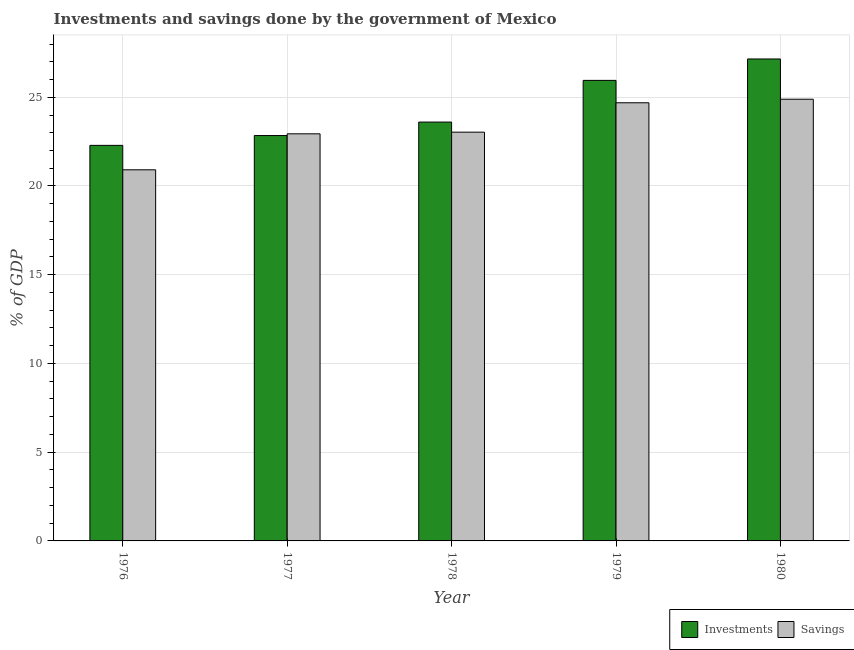How many groups of bars are there?
Provide a succinct answer. 5. Are the number of bars per tick equal to the number of legend labels?
Your response must be concise. Yes. Are the number of bars on each tick of the X-axis equal?
Give a very brief answer. Yes. How many bars are there on the 1st tick from the left?
Ensure brevity in your answer.  2. How many bars are there on the 3rd tick from the right?
Make the answer very short. 2. What is the label of the 4th group of bars from the left?
Give a very brief answer. 1979. In how many cases, is the number of bars for a given year not equal to the number of legend labels?
Your answer should be compact. 0. What is the savings of government in 1977?
Ensure brevity in your answer.  22.94. Across all years, what is the maximum savings of government?
Ensure brevity in your answer.  24.89. Across all years, what is the minimum savings of government?
Keep it short and to the point. 20.91. In which year was the savings of government minimum?
Ensure brevity in your answer.  1976. What is the total investments of government in the graph?
Provide a succinct answer. 121.84. What is the difference between the investments of government in 1976 and that in 1978?
Ensure brevity in your answer.  -1.31. What is the difference between the savings of government in 1978 and the investments of government in 1977?
Offer a terse response. 0.09. What is the average investments of government per year?
Offer a terse response. 24.37. In how many years, is the investments of government greater than 10 %?
Ensure brevity in your answer.  5. What is the ratio of the savings of government in 1976 to that in 1980?
Offer a very short reply. 0.84. Is the savings of government in 1976 less than that in 1978?
Provide a succinct answer. Yes. Is the difference between the investments of government in 1976 and 1980 greater than the difference between the savings of government in 1976 and 1980?
Provide a short and direct response. No. What is the difference between the highest and the second highest savings of government?
Keep it short and to the point. 0.2. What is the difference between the highest and the lowest savings of government?
Give a very brief answer. 3.98. In how many years, is the investments of government greater than the average investments of government taken over all years?
Make the answer very short. 2. Is the sum of the investments of government in 1976 and 1977 greater than the maximum savings of government across all years?
Your answer should be very brief. Yes. What does the 1st bar from the left in 1980 represents?
Ensure brevity in your answer.  Investments. What does the 2nd bar from the right in 1978 represents?
Your answer should be compact. Investments. How many years are there in the graph?
Provide a short and direct response. 5. What is the difference between two consecutive major ticks on the Y-axis?
Offer a very short reply. 5. Are the values on the major ticks of Y-axis written in scientific E-notation?
Your answer should be very brief. No. Does the graph contain any zero values?
Ensure brevity in your answer.  No. Does the graph contain grids?
Your response must be concise. Yes. How are the legend labels stacked?
Ensure brevity in your answer.  Horizontal. What is the title of the graph?
Your answer should be compact. Investments and savings done by the government of Mexico. Does "Public funds" appear as one of the legend labels in the graph?
Provide a short and direct response. No. What is the label or title of the X-axis?
Offer a terse response. Year. What is the label or title of the Y-axis?
Ensure brevity in your answer.  % of GDP. What is the % of GDP of Investments in 1976?
Provide a short and direct response. 22.29. What is the % of GDP in Savings in 1976?
Offer a very short reply. 20.91. What is the % of GDP of Investments in 1977?
Your response must be concise. 22.84. What is the % of GDP of Savings in 1977?
Keep it short and to the point. 22.94. What is the % of GDP in Investments in 1978?
Ensure brevity in your answer.  23.6. What is the % of GDP in Savings in 1978?
Offer a very short reply. 23.03. What is the % of GDP of Investments in 1979?
Offer a terse response. 25.95. What is the % of GDP of Savings in 1979?
Keep it short and to the point. 24.69. What is the % of GDP of Investments in 1980?
Provide a short and direct response. 27.16. What is the % of GDP of Savings in 1980?
Give a very brief answer. 24.89. Across all years, what is the maximum % of GDP in Investments?
Give a very brief answer. 27.16. Across all years, what is the maximum % of GDP of Savings?
Your answer should be very brief. 24.89. Across all years, what is the minimum % of GDP of Investments?
Provide a succinct answer. 22.29. Across all years, what is the minimum % of GDP in Savings?
Make the answer very short. 20.91. What is the total % of GDP in Investments in the graph?
Your response must be concise. 121.84. What is the total % of GDP of Savings in the graph?
Offer a terse response. 116.46. What is the difference between the % of GDP of Investments in 1976 and that in 1977?
Ensure brevity in your answer.  -0.55. What is the difference between the % of GDP in Savings in 1976 and that in 1977?
Provide a short and direct response. -2.03. What is the difference between the % of GDP in Investments in 1976 and that in 1978?
Provide a succinct answer. -1.31. What is the difference between the % of GDP of Savings in 1976 and that in 1978?
Provide a succinct answer. -2.12. What is the difference between the % of GDP in Investments in 1976 and that in 1979?
Offer a very short reply. -3.66. What is the difference between the % of GDP in Savings in 1976 and that in 1979?
Offer a very short reply. -3.78. What is the difference between the % of GDP of Investments in 1976 and that in 1980?
Give a very brief answer. -4.87. What is the difference between the % of GDP of Savings in 1976 and that in 1980?
Provide a succinct answer. -3.98. What is the difference between the % of GDP of Investments in 1977 and that in 1978?
Give a very brief answer. -0.76. What is the difference between the % of GDP of Savings in 1977 and that in 1978?
Your response must be concise. -0.09. What is the difference between the % of GDP of Investments in 1977 and that in 1979?
Keep it short and to the point. -3.11. What is the difference between the % of GDP in Savings in 1977 and that in 1979?
Give a very brief answer. -1.75. What is the difference between the % of GDP of Investments in 1977 and that in 1980?
Give a very brief answer. -4.31. What is the difference between the % of GDP in Savings in 1977 and that in 1980?
Make the answer very short. -1.95. What is the difference between the % of GDP in Investments in 1978 and that in 1979?
Provide a short and direct response. -2.35. What is the difference between the % of GDP of Savings in 1978 and that in 1979?
Ensure brevity in your answer.  -1.66. What is the difference between the % of GDP of Investments in 1978 and that in 1980?
Provide a succinct answer. -3.56. What is the difference between the % of GDP of Savings in 1978 and that in 1980?
Provide a short and direct response. -1.86. What is the difference between the % of GDP in Investments in 1979 and that in 1980?
Ensure brevity in your answer.  -1.21. What is the difference between the % of GDP of Savings in 1979 and that in 1980?
Provide a succinct answer. -0.2. What is the difference between the % of GDP of Investments in 1976 and the % of GDP of Savings in 1977?
Your response must be concise. -0.65. What is the difference between the % of GDP of Investments in 1976 and the % of GDP of Savings in 1978?
Ensure brevity in your answer.  -0.74. What is the difference between the % of GDP in Investments in 1976 and the % of GDP in Savings in 1979?
Offer a very short reply. -2.4. What is the difference between the % of GDP in Investments in 1976 and the % of GDP in Savings in 1980?
Your answer should be very brief. -2.6. What is the difference between the % of GDP in Investments in 1977 and the % of GDP in Savings in 1978?
Give a very brief answer. -0.19. What is the difference between the % of GDP of Investments in 1977 and the % of GDP of Savings in 1979?
Offer a very short reply. -1.85. What is the difference between the % of GDP of Investments in 1977 and the % of GDP of Savings in 1980?
Make the answer very short. -2.05. What is the difference between the % of GDP of Investments in 1978 and the % of GDP of Savings in 1979?
Offer a very short reply. -1.09. What is the difference between the % of GDP in Investments in 1978 and the % of GDP in Savings in 1980?
Your response must be concise. -1.29. What is the difference between the % of GDP in Investments in 1979 and the % of GDP in Savings in 1980?
Ensure brevity in your answer.  1.06. What is the average % of GDP in Investments per year?
Your answer should be compact. 24.37. What is the average % of GDP of Savings per year?
Provide a short and direct response. 23.29. In the year 1976, what is the difference between the % of GDP in Investments and % of GDP in Savings?
Give a very brief answer. 1.38. In the year 1977, what is the difference between the % of GDP of Investments and % of GDP of Savings?
Offer a terse response. -0.1. In the year 1978, what is the difference between the % of GDP of Investments and % of GDP of Savings?
Give a very brief answer. 0.57. In the year 1979, what is the difference between the % of GDP in Investments and % of GDP in Savings?
Your answer should be compact. 1.26. In the year 1980, what is the difference between the % of GDP of Investments and % of GDP of Savings?
Provide a succinct answer. 2.27. What is the ratio of the % of GDP in Investments in 1976 to that in 1977?
Ensure brevity in your answer.  0.98. What is the ratio of the % of GDP of Savings in 1976 to that in 1977?
Ensure brevity in your answer.  0.91. What is the ratio of the % of GDP of Investments in 1976 to that in 1978?
Provide a succinct answer. 0.94. What is the ratio of the % of GDP in Savings in 1976 to that in 1978?
Keep it short and to the point. 0.91. What is the ratio of the % of GDP in Investments in 1976 to that in 1979?
Give a very brief answer. 0.86. What is the ratio of the % of GDP of Savings in 1976 to that in 1979?
Your answer should be compact. 0.85. What is the ratio of the % of GDP of Investments in 1976 to that in 1980?
Keep it short and to the point. 0.82. What is the ratio of the % of GDP in Savings in 1976 to that in 1980?
Give a very brief answer. 0.84. What is the ratio of the % of GDP of Investments in 1977 to that in 1978?
Make the answer very short. 0.97. What is the ratio of the % of GDP of Savings in 1977 to that in 1978?
Your response must be concise. 1. What is the ratio of the % of GDP of Investments in 1977 to that in 1979?
Ensure brevity in your answer.  0.88. What is the ratio of the % of GDP in Savings in 1977 to that in 1979?
Make the answer very short. 0.93. What is the ratio of the % of GDP in Investments in 1977 to that in 1980?
Make the answer very short. 0.84. What is the ratio of the % of GDP of Savings in 1977 to that in 1980?
Your response must be concise. 0.92. What is the ratio of the % of GDP in Investments in 1978 to that in 1979?
Your answer should be very brief. 0.91. What is the ratio of the % of GDP in Savings in 1978 to that in 1979?
Your answer should be very brief. 0.93. What is the ratio of the % of GDP in Investments in 1978 to that in 1980?
Your answer should be compact. 0.87. What is the ratio of the % of GDP of Savings in 1978 to that in 1980?
Offer a terse response. 0.93. What is the ratio of the % of GDP in Investments in 1979 to that in 1980?
Give a very brief answer. 0.96. What is the ratio of the % of GDP in Savings in 1979 to that in 1980?
Your answer should be compact. 0.99. What is the difference between the highest and the second highest % of GDP in Investments?
Offer a terse response. 1.21. What is the difference between the highest and the second highest % of GDP in Savings?
Your answer should be very brief. 0.2. What is the difference between the highest and the lowest % of GDP in Investments?
Make the answer very short. 4.87. What is the difference between the highest and the lowest % of GDP of Savings?
Provide a succinct answer. 3.98. 